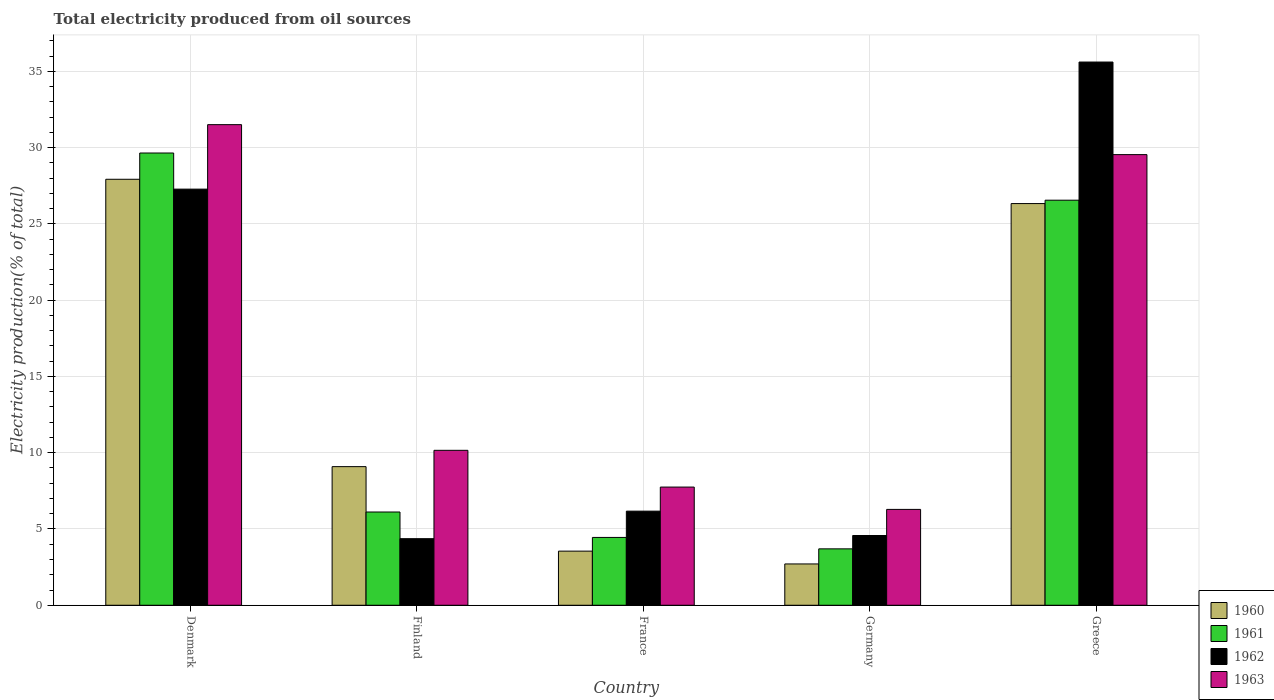How many different coloured bars are there?
Ensure brevity in your answer.  4. Are the number of bars on each tick of the X-axis equal?
Make the answer very short. Yes. How many bars are there on the 2nd tick from the left?
Your answer should be very brief. 4. How many bars are there on the 4th tick from the right?
Provide a short and direct response. 4. What is the label of the 4th group of bars from the left?
Give a very brief answer. Germany. In how many cases, is the number of bars for a given country not equal to the number of legend labels?
Your response must be concise. 0. What is the total electricity produced in 1962 in Denmark?
Your response must be concise. 27.28. Across all countries, what is the maximum total electricity produced in 1961?
Provide a short and direct response. 29.65. Across all countries, what is the minimum total electricity produced in 1962?
Provide a succinct answer. 4.36. In which country was the total electricity produced in 1960 maximum?
Offer a very short reply. Denmark. In which country was the total electricity produced in 1962 minimum?
Offer a very short reply. Finland. What is the total total electricity produced in 1963 in the graph?
Provide a short and direct response. 85.23. What is the difference between the total electricity produced in 1960 in France and that in Germany?
Ensure brevity in your answer.  0.84. What is the difference between the total electricity produced in 1963 in Greece and the total electricity produced in 1961 in Denmark?
Provide a short and direct response. -0.11. What is the average total electricity produced in 1963 per country?
Offer a terse response. 17.05. What is the difference between the total electricity produced of/in 1961 and total electricity produced of/in 1962 in Greece?
Your answer should be compact. -9.06. What is the ratio of the total electricity produced in 1962 in Denmark to that in France?
Offer a very short reply. 4.42. What is the difference between the highest and the second highest total electricity produced in 1960?
Provide a short and direct response. -17.24. What is the difference between the highest and the lowest total electricity produced in 1961?
Provide a short and direct response. 25.95. In how many countries, is the total electricity produced in 1962 greater than the average total electricity produced in 1962 taken over all countries?
Offer a terse response. 2. What does the 1st bar from the right in Greece represents?
Ensure brevity in your answer.  1963. Is it the case that in every country, the sum of the total electricity produced in 1962 and total electricity produced in 1963 is greater than the total electricity produced in 1960?
Your answer should be compact. Yes. How many countries are there in the graph?
Provide a succinct answer. 5. What is the difference between two consecutive major ticks on the Y-axis?
Provide a short and direct response. 5. Are the values on the major ticks of Y-axis written in scientific E-notation?
Give a very brief answer. No. Does the graph contain any zero values?
Your answer should be compact. No. Does the graph contain grids?
Provide a succinct answer. Yes. How many legend labels are there?
Ensure brevity in your answer.  4. How are the legend labels stacked?
Your answer should be very brief. Vertical. What is the title of the graph?
Offer a very short reply. Total electricity produced from oil sources. What is the label or title of the X-axis?
Make the answer very short. Country. What is the Electricity production(% of total) in 1960 in Denmark?
Offer a terse response. 27.92. What is the Electricity production(% of total) of 1961 in Denmark?
Provide a short and direct response. 29.65. What is the Electricity production(% of total) in 1962 in Denmark?
Make the answer very short. 27.28. What is the Electricity production(% of total) in 1963 in Denmark?
Offer a terse response. 31.51. What is the Electricity production(% of total) of 1960 in Finland?
Keep it short and to the point. 9.09. What is the Electricity production(% of total) in 1961 in Finland?
Provide a short and direct response. 6.11. What is the Electricity production(% of total) in 1962 in Finland?
Keep it short and to the point. 4.36. What is the Electricity production(% of total) of 1963 in Finland?
Make the answer very short. 10.16. What is the Electricity production(% of total) in 1960 in France?
Offer a very short reply. 3.55. What is the Electricity production(% of total) in 1961 in France?
Offer a very short reply. 4.45. What is the Electricity production(% of total) in 1962 in France?
Offer a terse response. 6.17. What is the Electricity production(% of total) in 1963 in France?
Your answer should be very brief. 7.75. What is the Electricity production(% of total) of 1960 in Germany?
Ensure brevity in your answer.  2.71. What is the Electricity production(% of total) of 1961 in Germany?
Your answer should be very brief. 3.7. What is the Electricity production(% of total) of 1962 in Germany?
Provide a short and direct response. 4.57. What is the Electricity production(% of total) of 1963 in Germany?
Provide a short and direct response. 6.28. What is the Electricity production(% of total) of 1960 in Greece?
Provide a short and direct response. 26.33. What is the Electricity production(% of total) of 1961 in Greece?
Your answer should be compact. 26.55. What is the Electricity production(% of total) of 1962 in Greece?
Make the answer very short. 35.61. What is the Electricity production(% of total) of 1963 in Greece?
Offer a very short reply. 29.54. Across all countries, what is the maximum Electricity production(% of total) of 1960?
Provide a succinct answer. 27.92. Across all countries, what is the maximum Electricity production(% of total) in 1961?
Ensure brevity in your answer.  29.65. Across all countries, what is the maximum Electricity production(% of total) in 1962?
Your answer should be compact. 35.61. Across all countries, what is the maximum Electricity production(% of total) of 1963?
Offer a very short reply. 31.51. Across all countries, what is the minimum Electricity production(% of total) in 1960?
Your answer should be compact. 2.71. Across all countries, what is the minimum Electricity production(% of total) of 1961?
Ensure brevity in your answer.  3.7. Across all countries, what is the minimum Electricity production(% of total) in 1962?
Give a very brief answer. 4.36. Across all countries, what is the minimum Electricity production(% of total) in 1963?
Provide a short and direct response. 6.28. What is the total Electricity production(% of total) of 1960 in the graph?
Offer a terse response. 69.6. What is the total Electricity production(% of total) of 1961 in the graph?
Give a very brief answer. 70.46. What is the total Electricity production(% of total) of 1962 in the graph?
Your answer should be very brief. 78. What is the total Electricity production(% of total) in 1963 in the graph?
Your answer should be compact. 85.23. What is the difference between the Electricity production(% of total) of 1960 in Denmark and that in Finland?
Ensure brevity in your answer.  18.84. What is the difference between the Electricity production(% of total) in 1961 in Denmark and that in Finland?
Your answer should be compact. 23.53. What is the difference between the Electricity production(% of total) of 1962 in Denmark and that in Finland?
Your answer should be compact. 22.91. What is the difference between the Electricity production(% of total) of 1963 in Denmark and that in Finland?
Your answer should be very brief. 21.35. What is the difference between the Electricity production(% of total) of 1960 in Denmark and that in France?
Give a very brief answer. 24.38. What is the difference between the Electricity production(% of total) in 1961 in Denmark and that in France?
Keep it short and to the point. 25.2. What is the difference between the Electricity production(% of total) of 1962 in Denmark and that in France?
Keep it short and to the point. 21.11. What is the difference between the Electricity production(% of total) in 1963 in Denmark and that in France?
Provide a succinct answer. 23.76. What is the difference between the Electricity production(% of total) in 1960 in Denmark and that in Germany?
Keep it short and to the point. 25.22. What is the difference between the Electricity production(% of total) of 1961 in Denmark and that in Germany?
Offer a terse response. 25.95. What is the difference between the Electricity production(% of total) of 1962 in Denmark and that in Germany?
Your answer should be compact. 22.71. What is the difference between the Electricity production(% of total) of 1963 in Denmark and that in Germany?
Provide a succinct answer. 25.22. What is the difference between the Electricity production(% of total) of 1960 in Denmark and that in Greece?
Your response must be concise. 1.59. What is the difference between the Electricity production(% of total) of 1961 in Denmark and that in Greece?
Make the answer very short. 3.09. What is the difference between the Electricity production(% of total) in 1962 in Denmark and that in Greece?
Your answer should be very brief. -8.33. What is the difference between the Electricity production(% of total) of 1963 in Denmark and that in Greece?
Provide a short and direct response. 1.96. What is the difference between the Electricity production(% of total) of 1960 in Finland and that in France?
Make the answer very short. 5.54. What is the difference between the Electricity production(% of total) of 1961 in Finland and that in France?
Give a very brief answer. 1.67. What is the difference between the Electricity production(% of total) of 1962 in Finland and that in France?
Make the answer very short. -1.8. What is the difference between the Electricity production(% of total) in 1963 in Finland and that in France?
Your response must be concise. 2.41. What is the difference between the Electricity production(% of total) in 1960 in Finland and that in Germany?
Offer a very short reply. 6.38. What is the difference between the Electricity production(% of total) of 1961 in Finland and that in Germany?
Provide a succinct answer. 2.41. What is the difference between the Electricity production(% of total) in 1962 in Finland and that in Germany?
Give a very brief answer. -0.21. What is the difference between the Electricity production(% of total) in 1963 in Finland and that in Germany?
Your response must be concise. 3.87. What is the difference between the Electricity production(% of total) in 1960 in Finland and that in Greece?
Provide a succinct answer. -17.24. What is the difference between the Electricity production(% of total) in 1961 in Finland and that in Greece?
Offer a terse response. -20.44. What is the difference between the Electricity production(% of total) of 1962 in Finland and that in Greece?
Provide a succinct answer. -31.25. What is the difference between the Electricity production(% of total) of 1963 in Finland and that in Greece?
Provide a short and direct response. -19.38. What is the difference between the Electricity production(% of total) of 1960 in France and that in Germany?
Offer a terse response. 0.84. What is the difference between the Electricity production(% of total) of 1961 in France and that in Germany?
Offer a terse response. 0.75. What is the difference between the Electricity production(% of total) of 1962 in France and that in Germany?
Make the answer very short. 1.6. What is the difference between the Electricity production(% of total) in 1963 in France and that in Germany?
Ensure brevity in your answer.  1.46. What is the difference between the Electricity production(% of total) of 1960 in France and that in Greece?
Your answer should be very brief. -22.78. What is the difference between the Electricity production(% of total) in 1961 in France and that in Greece?
Your response must be concise. -22.11. What is the difference between the Electricity production(% of total) in 1962 in France and that in Greece?
Make the answer very short. -29.44. What is the difference between the Electricity production(% of total) of 1963 in France and that in Greece?
Ensure brevity in your answer.  -21.79. What is the difference between the Electricity production(% of total) in 1960 in Germany and that in Greece?
Your answer should be very brief. -23.62. What is the difference between the Electricity production(% of total) of 1961 in Germany and that in Greece?
Your answer should be compact. -22.86. What is the difference between the Electricity production(% of total) of 1962 in Germany and that in Greece?
Ensure brevity in your answer.  -31.04. What is the difference between the Electricity production(% of total) of 1963 in Germany and that in Greece?
Offer a terse response. -23.26. What is the difference between the Electricity production(% of total) of 1960 in Denmark and the Electricity production(% of total) of 1961 in Finland?
Give a very brief answer. 21.81. What is the difference between the Electricity production(% of total) in 1960 in Denmark and the Electricity production(% of total) in 1962 in Finland?
Offer a very short reply. 23.56. What is the difference between the Electricity production(% of total) in 1960 in Denmark and the Electricity production(% of total) in 1963 in Finland?
Offer a very short reply. 17.77. What is the difference between the Electricity production(% of total) of 1961 in Denmark and the Electricity production(% of total) of 1962 in Finland?
Provide a succinct answer. 25.28. What is the difference between the Electricity production(% of total) in 1961 in Denmark and the Electricity production(% of total) in 1963 in Finland?
Offer a very short reply. 19.49. What is the difference between the Electricity production(% of total) in 1962 in Denmark and the Electricity production(% of total) in 1963 in Finland?
Keep it short and to the point. 17.12. What is the difference between the Electricity production(% of total) of 1960 in Denmark and the Electricity production(% of total) of 1961 in France?
Your response must be concise. 23.48. What is the difference between the Electricity production(% of total) of 1960 in Denmark and the Electricity production(% of total) of 1962 in France?
Offer a very short reply. 21.75. What is the difference between the Electricity production(% of total) in 1960 in Denmark and the Electricity production(% of total) in 1963 in France?
Ensure brevity in your answer.  20.18. What is the difference between the Electricity production(% of total) in 1961 in Denmark and the Electricity production(% of total) in 1962 in France?
Offer a very short reply. 23.48. What is the difference between the Electricity production(% of total) in 1961 in Denmark and the Electricity production(% of total) in 1963 in France?
Make the answer very short. 21.9. What is the difference between the Electricity production(% of total) of 1962 in Denmark and the Electricity production(% of total) of 1963 in France?
Offer a terse response. 19.53. What is the difference between the Electricity production(% of total) of 1960 in Denmark and the Electricity production(% of total) of 1961 in Germany?
Your answer should be very brief. 24.23. What is the difference between the Electricity production(% of total) of 1960 in Denmark and the Electricity production(% of total) of 1962 in Germany?
Your answer should be compact. 23.35. What is the difference between the Electricity production(% of total) of 1960 in Denmark and the Electricity production(% of total) of 1963 in Germany?
Your response must be concise. 21.64. What is the difference between the Electricity production(% of total) of 1961 in Denmark and the Electricity production(% of total) of 1962 in Germany?
Your response must be concise. 25.07. What is the difference between the Electricity production(% of total) of 1961 in Denmark and the Electricity production(% of total) of 1963 in Germany?
Your answer should be compact. 23.36. What is the difference between the Electricity production(% of total) in 1962 in Denmark and the Electricity production(% of total) in 1963 in Germany?
Give a very brief answer. 20.99. What is the difference between the Electricity production(% of total) of 1960 in Denmark and the Electricity production(% of total) of 1961 in Greece?
Your answer should be very brief. 1.37. What is the difference between the Electricity production(% of total) of 1960 in Denmark and the Electricity production(% of total) of 1962 in Greece?
Your response must be concise. -7.69. What is the difference between the Electricity production(% of total) in 1960 in Denmark and the Electricity production(% of total) in 1963 in Greece?
Offer a very short reply. -1.62. What is the difference between the Electricity production(% of total) of 1961 in Denmark and the Electricity production(% of total) of 1962 in Greece?
Your response must be concise. -5.96. What is the difference between the Electricity production(% of total) of 1961 in Denmark and the Electricity production(% of total) of 1963 in Greece?
Ensure brevity in your answer.  0.11. What is the difference between the Electricity production(% of total) in 1962 in Denmark and the Electricity production(% of total) in 1963 in Greece?
Your answer should be very brief. -2.26. What is the difference between the Electricity production(% of total) of 1960 in Finland and the Electricity production(% of total) of 1961 in France?
Offer a very short reply. 4.64. What is the difference between the Electricity production(% of total) of 1960 in Finland and the Electricity production(% of total) of 1962 in France?
Keep it short and to the point. 2.92. What is the difference between the Electricity production(% of total) in 1960 in Finland and the Electricity production(% of total) in 1963 in France?
Offer a terse response. 1.34. What is the difference between the Electricity production(% of total) of 1961 in Finland and the Electricity production(% of total) of 1962 in France?
Ensure brevity in your answer.  -0.06. What is the difference between the Electricity production(% of total) in 1961 in Finland and the Electricity production(% of total) in 1963 in France?
Your answer should be compact. -1.64. What is the difference between the Electricity production(% of total) in 1962 in Finland and the Electricity production(% of total) in 1963 in France?
Your answer should be compact. -3.38. What is the difference between the Electricity production(% of total) of 1960 in Finland and the Electricity production(% of total) of 1961 in Germany?
Make the answer very short. 5.39. What is the difference between the Electricity production(% of total) of 1960 in Finland and the Electricity production(% of total) of 1962 in Germany?
Keep it short and to the point. 4.51. What is the difference between the Electricity production(% of total) in 1960 in Finland and the Electricity production(% of total) in 1963 in Germany?
Provide a short and direct response. 2.8. What is the difference between the Electricity production(% of total) in 1961 in Finland and the Electricity production(% of total) in 1962 in Germany?
Provide a short and direct response. 1.54. What is the difference between the Electricity production(% of total) of 1961 in Finland and the Electricity production(% of total) of 1963 in Germany?
Provide a succinct answer. -0.17. What is the difference between the Electricity production(% of total) in 1962 in Finland and the Electricity production(% of total) in 1963 in Germany?
Make the answer very short. -1.92. What is the difference between the Electricity production(% of total) of 1960 in Finland and the Electricity production(% of total) of 1961 in Greece?
Offer a terse response. -17.47. What is the difference between the Electricity production(% of total) of 1960 in Finland and the Electricity production(% of total) of 1962 in Greece?
Your answer should be very brief. -26.52. What is the difference between the Electricity production(% of total) of 1960 in Finland and the Electricity production(% of total) of 1963 in Greece?
Your answer should be compact. -20.45. What is the difference between the Electricity production(% of total) of 1961 in Finland and the Electricity production(% of total) of 1962 in Greece?
Offer a terse response. -29.5. What is the difference between the Electricity production(% of total) of 1961 in Finland and the Electricity production(% of total) of 1963 in Greece?
Your response must be concise. -23.43. What is the difference between the Electricity production(% of total) in 1962 in Finland and the Electricity production(% of total) in 1963 in Greece?
Your answer should be very brief. -25.18. What is the difference between the Electricity production(% of total) in 1960 in France and the Electricity production(% of total) in 1961 in Germany?
Offer a very short reply. -0.15. What is the difference between the Electricity production(% of total) of 1960 in France and the Electricity production(% of total) of 1962 in Germany?
Keep it short and to the point. -1.02. What is the difference between the Electricity production(% of total) of 1960 in France and the Electricity production(% of total) of 1963 in Germany?
Ensure brevity in your answer.  -2.74. What is the difference between the Electricity production(% of total) in 1961 in France and the Electricity production(% of total) in 1962 in Germany?
Provide a short and direct response. -0.13. What is the difference between the Electricity production(% of total) of 1961 in France and the Electricity production(% of total) of 1963 in Germany?
Your answer should be compact. -1.84. What is the difference between the Electricity production(% of total) in 1962 in France and the Electricity production(% of total) in 1963 in Germany?
Make the answer very short. -0.11. What is the difference between the Electricity production(% of total) of 1960 in France and the Electricity production(% of total) of 1961 in Greece?
Your answer should be compact. -23.01. What is the difference between the Electricity production(% of total) in 1960 in France and the Electricity production(% of total) in 1962 in Greece?
Your response must be concise. -32.06. What is the difference between the Electricity production(% of total) of 1960 in France and the Electricity production(% of total) of 1963 in Greece?
Keep it short and to the point. -25.99. What is the difference between the Electricity production(% of total) of 1961 in France and the Electricity production(% of total) of 1962 in Greece?
Your answer should be very brief. -31.16. What is the difference between the Electricity production(% of total) of 1961 in France and the Electricity production(% of total) of 1963 in Greece?
Offer a very short reply. -25.09. What is the difference between the Electricity production(% of total) in 1962 in France and the Electricity production(% of total) in 1963 in Greece?
Make the answer very short. -23.37. What is the difference between the Electricity production(% of total) in 1960 in Germany and the Electricity production(% of total) in 1961 in Greece?
Your response must be concise. -23.85. What is the difference between the Electricity production(% of total) of 1960 in Germany and the Electricity production(% of total) of 1962 in Greece?
Your response must be concise. -32.9. What is the difference between the Electricity production(% of total) of 1960 in Germany and the Electricity production(% of total) of 1963 in Greece?
Keep it short and to the point. -26.83. What is the difference between the Electricity production(% of total) of 1961 in Germany and the Electricity production(% of total) of 1962 in Greece?
Ensure brevity in your answer.  -31.91. What is the difference between the Electricity production(% of total) in 1961 in Germany and the Electricity production(% of total) in 1963 in Greece?
Your response must be concise. -25.84. What is the difference between the Electricity production(% of total) of 1962 in Germany and the Electricity production(% of total) of 1963 in Greece?
Provide a succinct answer. -24.97. What is the average Electricity production(% of total) in 1960 per country?
Provide a short and direct response. 13.92. What is the average Electricity production(% of total) of 1961 per country?
Provide a succinct answer. 14.09. What is the average Electricity production(% of total) of 1962 per country?
Provide a short and direct response. 15.6. What is the average Electricity production(% of total) of 1963 per country?
Your response must be concise. 17.05. What is the difference between the Electricity production(% of total) in 1960 and Electricity production(% of total) in 1961 in Denmark?
Your answer should be compact. -1.72. What is the difference between the Electricity production(% of total) in 1960 and Electricity production(% of total) in 1962 in Denmark?
Provide a short and direct response. 0.65. What is the difference between the Electricity production(% of total) in 1960 and Electricity production(% of total) in 1963 in Denmark?
Your response must be concise. -3.58. What is the difference between the Electricity production(% of total) of 1961 and Electricity production(% of total) of 1962 in Denmark?
Offer a very short reply. 2.37. What is the difference between the Electricity production(% of total) in 1961 and Electricity production(% of total) in 1963 in Denmark?
Your response must be concise. -1.86. What is the difference between the Electricity production(% of total) of 1962 and Electricity production(% of total) of 1963 in Denmark?
Your answer should be very brief. -4.23. What is the difference between the Electricity production(% of total) in 1960 and Electricity production(% of total) in 1961 in Finland?
Offer a very short reply. 2.98. What is the difference between the Electricity production(% of total) of 1960 and Electricity production(% of total) of 1962 in Finland?
Offer a terse response. 4.72. What is the difference between the Electricity production(% of total) in 1960 and Electricity production(% of total) in 1963 in Finland?
Your answer should be compact. -1.07. What is the difference between the Electricity production(% of total) in 1961 and Electricity production(% of total) in 1962 in Finland?
Your response must be concise. 1.75. What is the difference between the Electricity production(% of total) in 1961 and Electricity production(% of total) in 1963 in Finland?
Offer a terse response. -4.04. What is the difference between the Electricity production(% of total) in 1962 and Electricity production(% of total) in 1963 in Finland?
Keep it short and to the point. -5.79. What is the difference between the Electricity production(% of total) of 1960 and Electricity production(% of total) of 1961 in France?
Give a very brief answer. -0.9. What is the difference between the Electricity production(% of total) of 1960 and Electricity production(% of total) of 1962 in France?
Your response must be concise. -2.62. What is the difference between the Electricity production(% of total) of 1960 and Electricity production(% of total) of 1963 in France?
Offer a terse response. -4.2. What is the difference between the Electricity production(% of total) of 1961 and Electricity production(% of total) of 1962 in France?
Give a very brief answer. -1.72. What is the difference between the Electricity production(% of total) of 1961 and Electricity production(% of total) of 1963 in France?
Your response must be concise. -3.3. What is the difference between the Electricity production(% of total) in 1962 and Electricity production(% of total) in 1963 in France?
Give a very brief answer. -1.58. What is the difference between the Electricity production(% of total) in 1960 and Electricity production(% of total) in 1961 in Germany?
Your answer should be compact. -0.99. What is the difference between the Electricity production(% of total) in 1960 and Electricity production(% of total) in 1962 in Germany?
Ensure brevity in your answer.  -1.86. What is the difference between the Electricity production(% of total) of 1960 and Electricity production(% of total) of 1963 in Germany?
Offer a very short reply. -3.58. What is the difference between the Electricity production(% of total) of 1961 and Electricity production(% of total) of 1962 in Germany?
Ensure brevity in your answer.  -0.87. What is the difference between the Electricity production(% of total) in 1961 and Electricity production(% of total) in 1963 in Germany?
Your answer should be very brief. -2.59. What is the difference between the Electricity production(% of total) of 1962 and Electricity production(% of total) of 1963 in Germany?
Ensure brevity in your answer.  -1.71. What is the difference between the Electricity production(% of total) in 1960 and Electricity production(% of total) in 1961 in Greece?
Your answer should be very brief. -0.22. What is the difference between the Electricity production(% of total) of 1960 and Electricity production(% of total) of 1962 in Greece?
Make the answer very short. -9.28. What is the difference between the Electricity production(% of total) in 1960 and Electricity production(% of total) in 1963 in Greece?
Provide a succinct answer. -3.21. What is the difference between the Electricity production(% of total) in 1961 and Electricity production(% of total) in 1962 in Greece?
Your response must be concise. -9.06. What is the difference between the Electricity production(% of total) of 1961 and Electricity production(% of total) of 1963 in Greece?
Make the answer very short. -2.99. What is the difference between the Electricity production(% of total) of 1962 and Electricity production(% of total) of 1963 in Greece?
Your answer should be compact. 6.07. What is the ratio of the Electricity production(% of total) in 1960 in Denmark to that in Finland?
Offer a terse response. 3.07. What is the ratio of the Electricity production(% of total) in 1961 in Denmark to that in Finland?
Your answer should be compact. 4.85. What is the ratio of the Electricity production(% of total) of 1962 in Denmark to that in Finland?
Keep it short and to the point. 6.25. What is the ratio of the Electricity production(% of total) in 1963 in Denmark to that in Finland?
Offer a very short reply. 3.1. What is the ratio of the Electricity production(% of total) in 1960 in Denmark to that in France?
Your response must be concise. 7.87. What is the ratio of the Electricity production(% of total) of 1961 in Denmark to that in France?
Offer a very short reply. 6.67. What is the ratio of the Electricity production(% of total) in 1962 in Denmark to that in France?
Your answer should be compact. 4.42. What is the ratio of the Electricity production(% of total) of 1963 in Denmark to that in France?
Provide a short and direct response. 4.07. What is the ratio of the Electricity production(% of total) in 1960 in Denmark to that in Germany?
Make the answer very short. 10.31. What is the ratio of the Electricity production(% of total) of 1961 in Denmark to that in Germany?
Offer a very short reply. 8.02. What is the ratio of the Electricity production(% of total) of 1962 in Denmark to that in Germany?
Your answer should be compact. 5.97. What is the ratio of the Electricity production(% of total) of 1963 in Denmark to that in Germany?
Your response must be concise. 5.01. What is the ratio of the Electricity production(% of total) in 1960 in Denmark to that in Greece?
Provide a short and direct response. 1.06. What is the ratio of the Electricity production(% of total) of 1961 in Denmark to that in Greece?
Ensure brevity in your answer.  1.12. What is the ratio of the Electricity production(% of total) in 1962 in Denmark to that in Greece?
Your answer should be compact. 0.77. What is the ratio of the Electricity production(% of total) of 1963 in Denmark to that in Greece?
Give a very brief answer. 1.07. What is the ratio of the Electricity production(% of total) of 1960 in Finland to that in France?
Offer a very short reply. 2.56. What is the ratio of the Electricity production(% of total) of 1961 in Finland to that in France?
Your answer should be very brief. 1.37. What is the ratio of the Electricity production(% of total) of 1962 in Finland to that in France?
Keep it short and to the point. 0.71. What is the ratio of the Electricity production(% of total) in 1963 in Finland to that in France?
Keep it short and to the point. 1.31. What is the ratio of the Electricity production(% of total) in 1960 in Finland to that in Germany?
Ensure brevity in your answer.  3.36. What is the ratio of the Electricity production(% of total) in 1961 in Finland to that in Germany?
Your answer should be very brief. 1.65. What is the ratio of the Electricity production(% of total) in 1962 in Finland to that in Germany?
Provide a succinct answer. 0.95. What is the ratio of the Electricity production(% of total) of 1963 in Finland to that in Germany?
Keep it short and to the point. 1.62. What is the ratio of the Electricity production(% of total) of 1960 in Finland to that in Greece?
Your answer should be compact. 0.35. What is the ratio of the Electricity production(% of total) in 1961 in Finland to that in Greece?
Give a very brief answer. 0.23. What is the ratio of the Electricity production(% of total) of 1962 in Finland to that in Greece?
Keep it short and to the point. 0.12. What is the ratio of the Electricity production(% of total) of 1963 in Finland to that in Greece?
Make the answer very short. 0.34. What is the ratio of the Electricity production(% of total) in 1960 in France to that in Germany?
Give a very brief answer. 1.31. What is the ratio of the Electricity production(% of total) in 1961 in France to that in Germany?
Give a very brief answer. 1.2. What is the ratio of the Electricity production(% of total) of 1962 in France to that in Germany?
Give a very brief answer. 1.35. What is the ratio of the Electricity production(% of total) in 1963 in France to that in Germany?
Your response must be concise. 1.23. What is the ratio of the Electricity production(% of total) in 1960 in France to that in Greece?
Ensure brevity in your answer.  0.13. What is the ratio of the Electricity production(% of total) in 1961 in France to that in Greece?
Provide a short and direct response. 0.17. What is the ratio of the Electricity production(% of total) in 1962 in France to that in Greece?
Make the answer very short. 0.17. What is the ratio of the Electricity production(% of total) of 1963 in France to that in Greece?
Provide a short and direct response. 0.26. What is the ratio of the Electricity production(% of total) of 1960 in Germany to that in Greece?
Your response must be concise. 0.1. What is the ratio of the Electricity production(% of total) of 1961 in Germany to that in Greece?
Keep it short and to the point. 0.14. What is the ratio of the Electricity production(% of total) of 1962 in Germany to that in Greece?
Provide a short and direct response. 0.13. What is the ratio of the Electricity production(% of total) in 1963 in Germany to that in Greece?
Provide a succinct answer. 0.21. What is the difference between the highest and the second highest Electricity production(% of total) of 1960?
Provide a succinct answer. 1.59. What is the difference between the highest and the second highest Electricity production(% of total) of 1961?
Provide a succinct answer. 3.09. What is the difference between the highest and the second highest Electricity production(% of total) of 1962?
Ensure brevity in your answer.  8.33. What is the difference between the highest and the second highest Electricity production(% of total) of 1963?
Provide a short and direct response. 1.96. What is the difference between the highest and the lowest Electricity production(% of total) in 1960?
Make the answer very short. 25.22. What is the difference between the highest and the lowest Electricity production(% of total) in 1961?
Ensure brevity in your answer.  25.95. What is the difference between the highest and the lowest Electricity production(% of total) of 1962?
Offer a terse response. 31.25. What is the difference between the highest and the lowest Electricity production(% of total) in 1963?
Your answer should be compact. 25.22. 